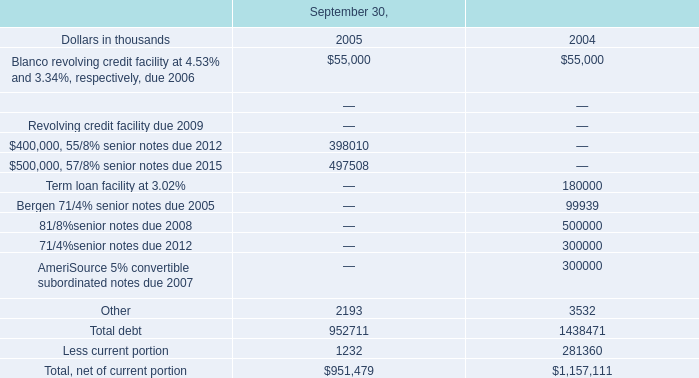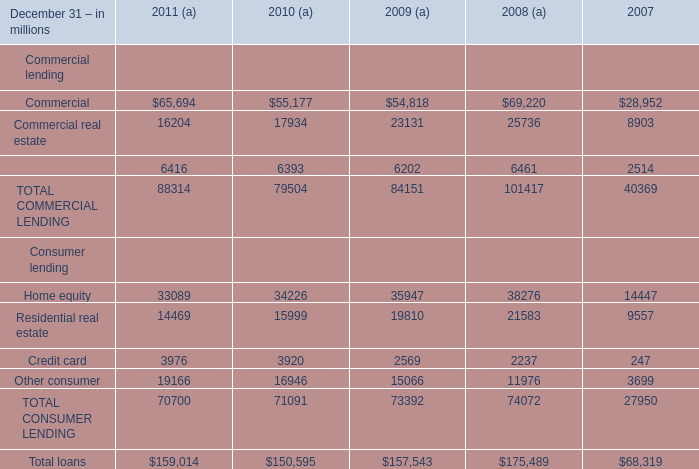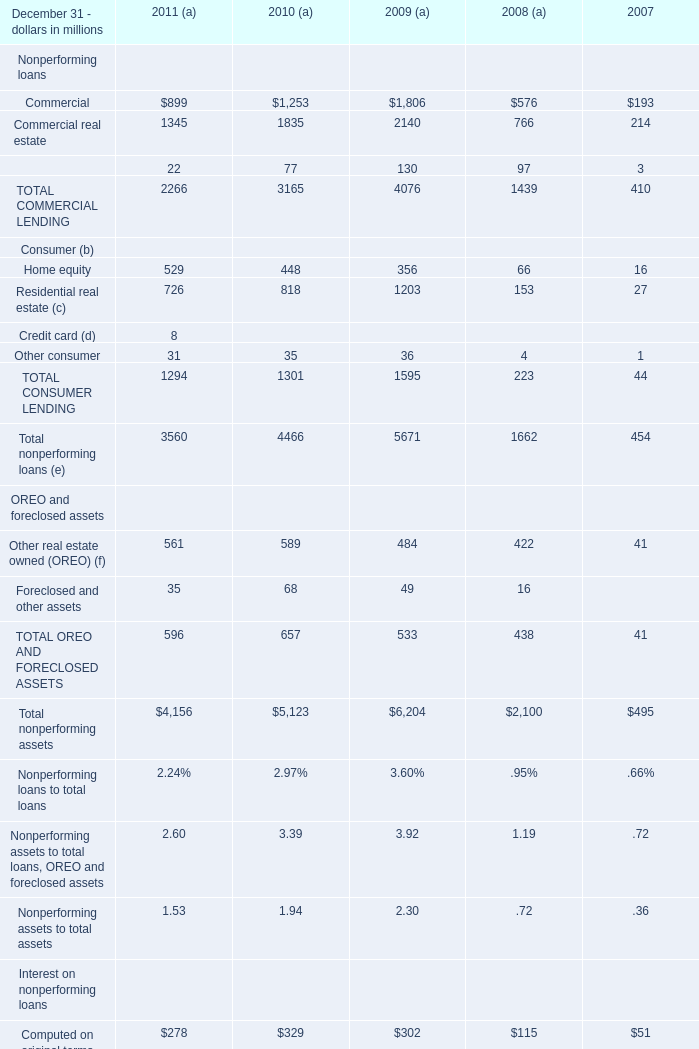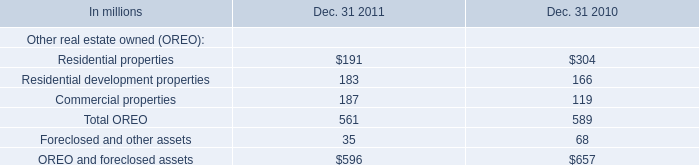What was the average of Equipment lease financing in2011 (a) 2010 (a) 2009 (a) (in million) 
Computations: (((22 + 77) + 130) / 3)
Answer: 76.33333. 